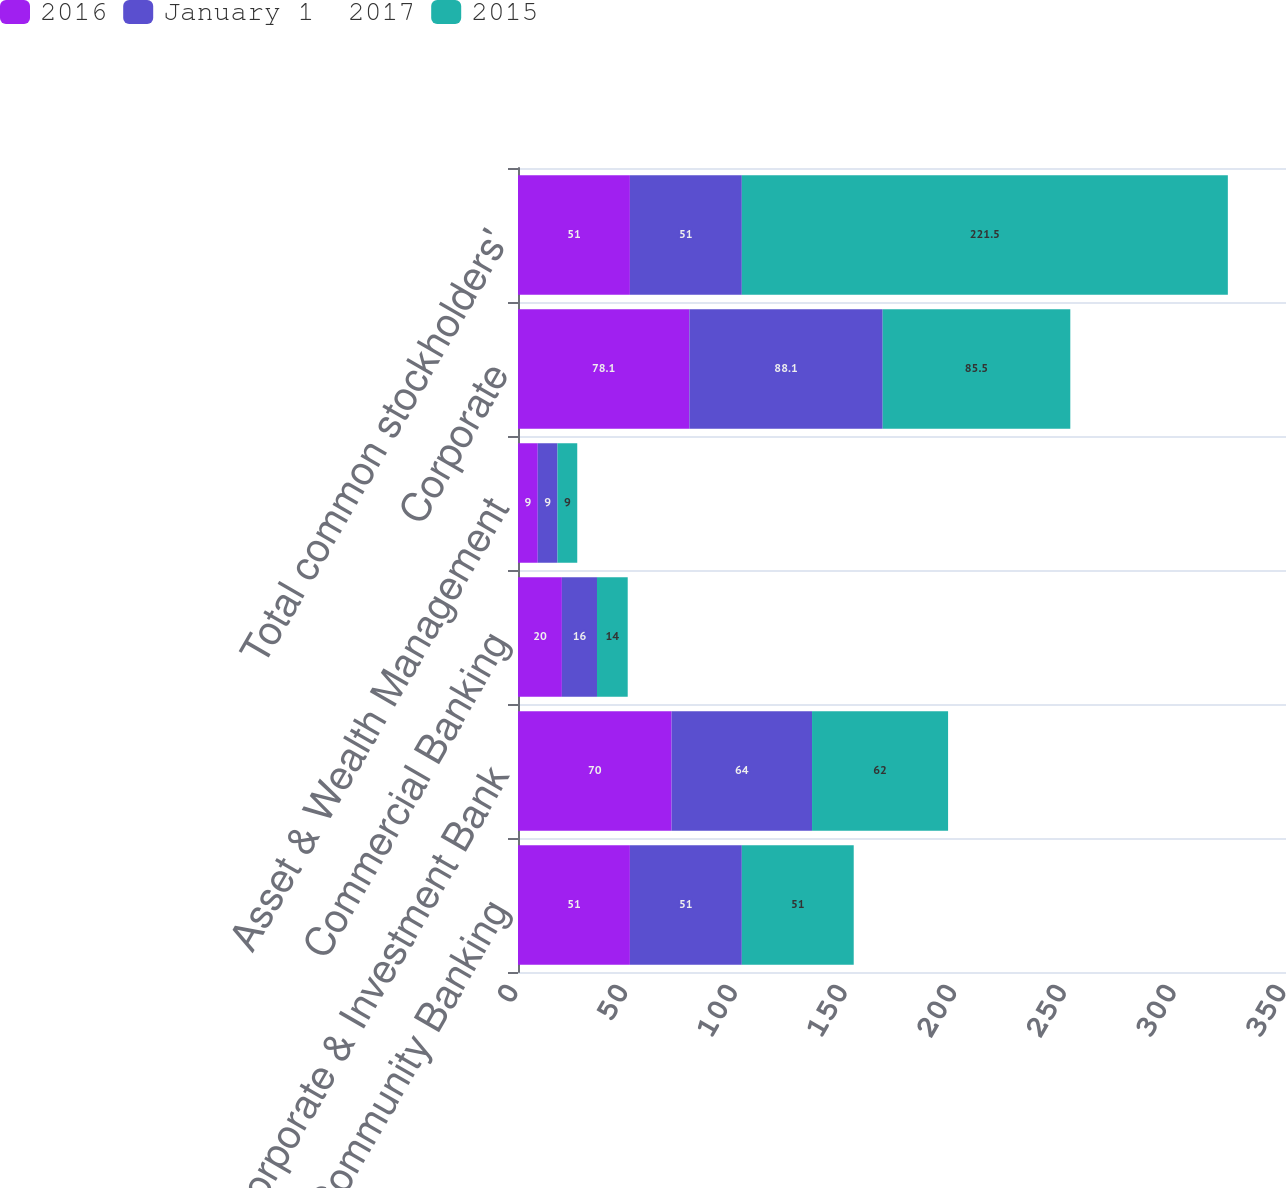<chart> <loc_0><loc_0><loc_500><loc_500><stacked_bar_chart><ecel><fcel>Consumer & Community Banking<fcel>Corporate & Investment Bank<fcel>Commercial Banking<fcel>Asset & Wealth Management<fcel>Corporate<fcel>Total common stockholders'<nl><fcel>2016<fcel>51<fcel>70<fcel>20<fcel>9<fcel>78.1<fcel>51<nl><fcel>January 1  2017<fcel>51<fcel>64<fcel>16<fcel>9<fcel>88.1<fcel>51<nl><fcel>2015<fcel>51<fcel>62<fcel>14<fcel>9<fcel>85.5<fcel>221.5<nl></chart> 